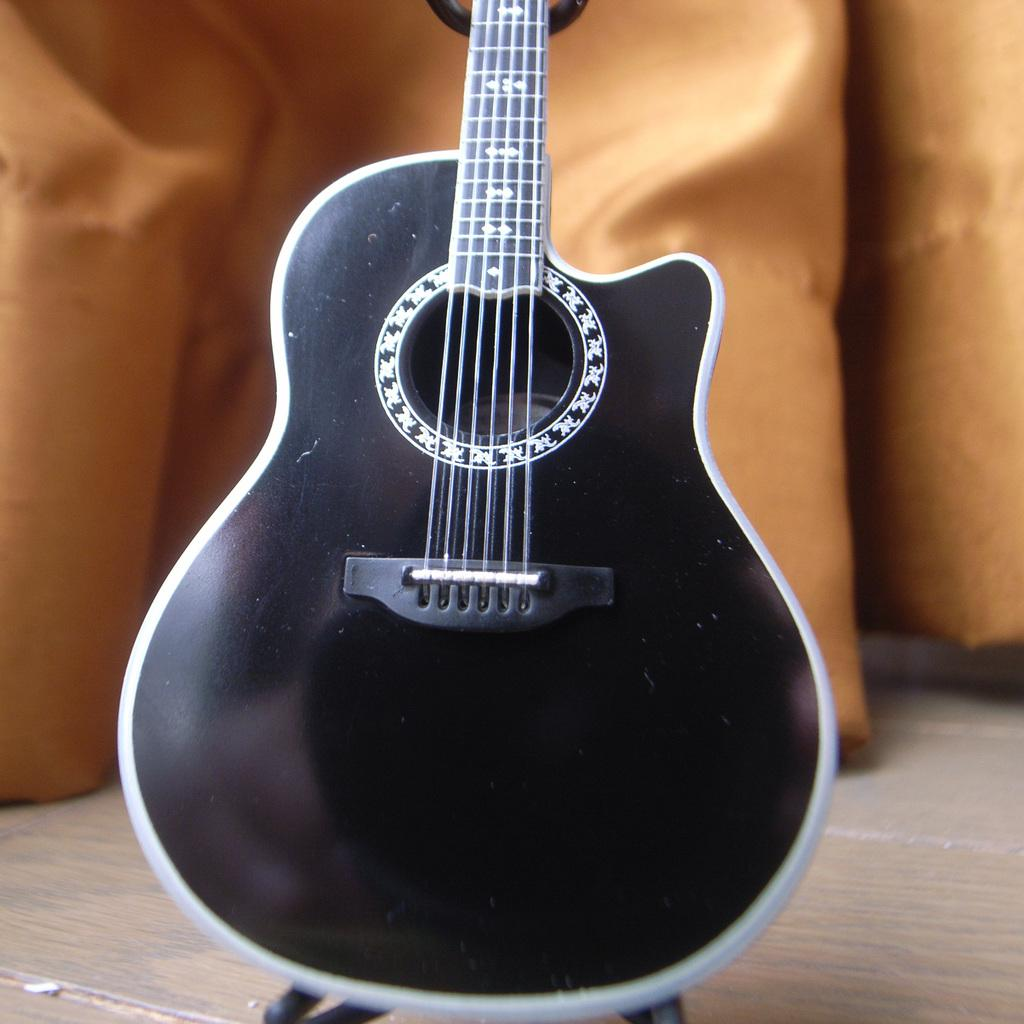What type of musical instrument is in the image? There is a black color guitar in the image. How is the guitar positioned in the image? The guitar is placed on a stand. What can be seen in the background of the image? There is a cloth visible in the background of the image. Can you hear the guitar laughing in the image? There is no sound or indication of laughter in the image; it is a still photograph of a guitar on a stand. 